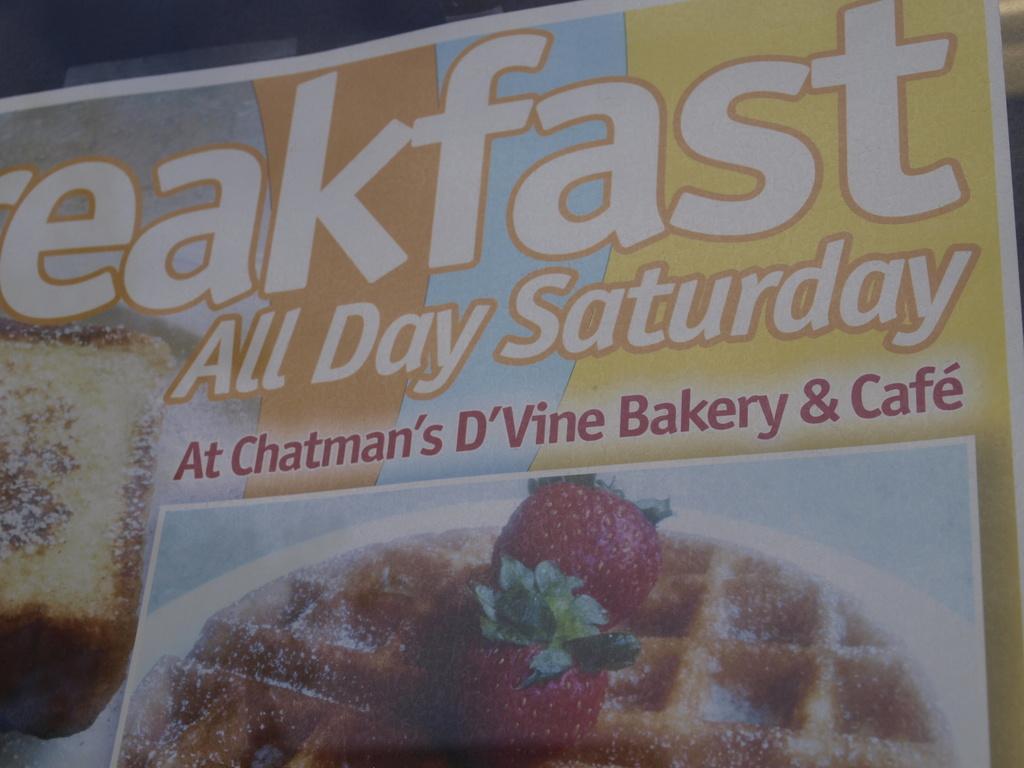Can you describe this image briefly? In this picture, we see a board or a poster in brown, blue and yellow color with some text written on it. At the bottom, we see the poster of a food item. 